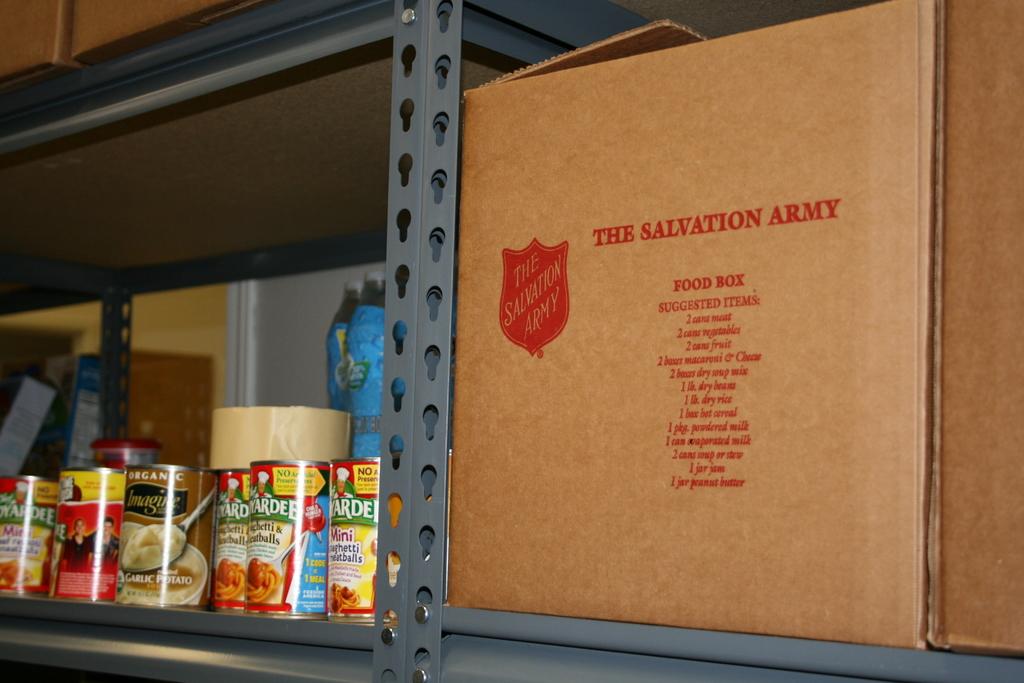Where did the box come from?
Give a very brief answer. The salvation army. Whats inside the box?
Give a very brief answer. Food. 